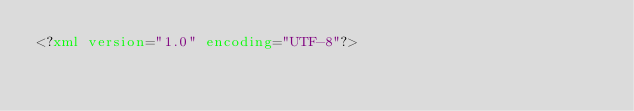<code> <loc_0><loc_0><loc_500><loc_500><_XML_><?xml version="1.0" encoding="UTF-8"?></code> 